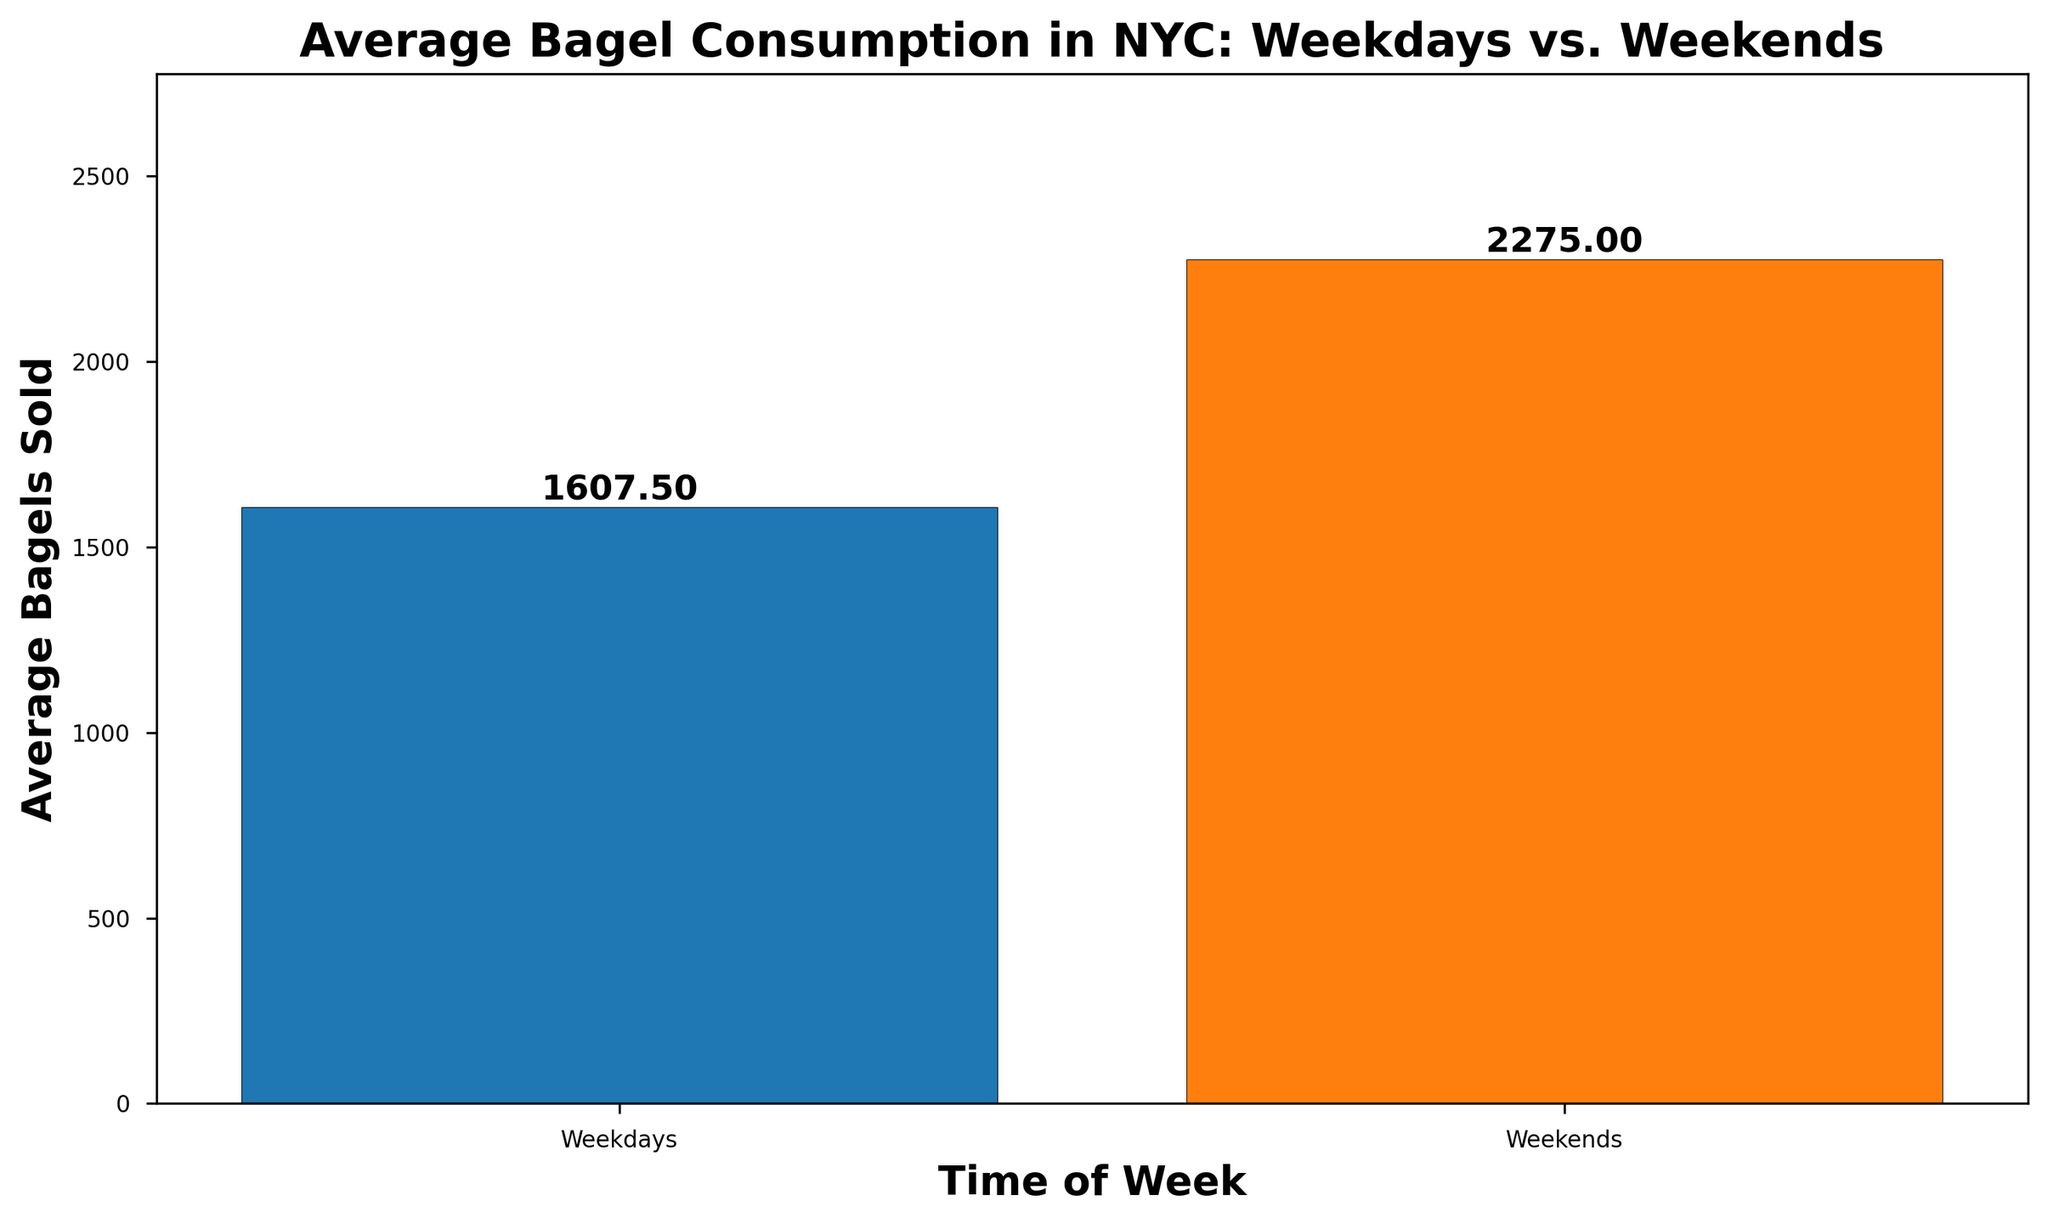Which time of the week has a higher average bagel consumption? The bar chart shows two bars for Weekdays and Weekends. The bar for Weekends is taller than the one for Weekdays, indicating a higher average bagel consumption.
Answer: Weekends What is the exact average number of bagels sold on weekends? The bar for Weekends has a label indicating the average number of bagels sold, which can be read directly from the chart.
Answer: 2275.00 How much more is the average bagel consumption on weekends compared to weekdays? Subtract the average bagels sold during weekdays (1632.00) from the average sold during weekends (2275.00).
Answer: 643.00 Which day categories are shown in the chart? The chart has two bars, each labeled as Weekdays and Weekends, indicating the categories being compared.
Answer: Weekdays, Weekends If bagel consumption on weekdays increases by 10%, what would be the new average? Calculate a 10% increase on the average weekday consumption: \(1632.00 \times 1.10 = 1795.20\).
Answer: 1795.20 Is the difference between average weekday and weekend bagel consumption visually significant? The difference is visually significant as the bar for Weekends is notably taller than the bar for Weekdays, indicating a noticeable difference in the averages.
Answer: Yes By how much does the bar representing weekends exceed the value on the y-axis? Read the height of the weekend bar from the chart, which stands at 2275.00 bagels, and compare it directly with the weekday bar height. The visual difference is 643 units, as the weekday bar stands at 1632.00.
Answer: 643 units What is the color of the bar representing weekdays? The bar representing weekdays is colored blue, as shown in the chart.
Answer: Blue How high would the average bagel consumption on weekends need to be to double the weekdays' average? Double the weekday average: \(1632.00 \times 2 = 3264.00\). Thus, the weekend's average would need to be 3264.00 to be double.
Answer: 3264.00 Does the average weekend bagel consumption reach or exceed 2500 bagels? The labeled value on the weekend bar is 2275.00, which does not reach or exceed 2500 bagels.
Answer: No 